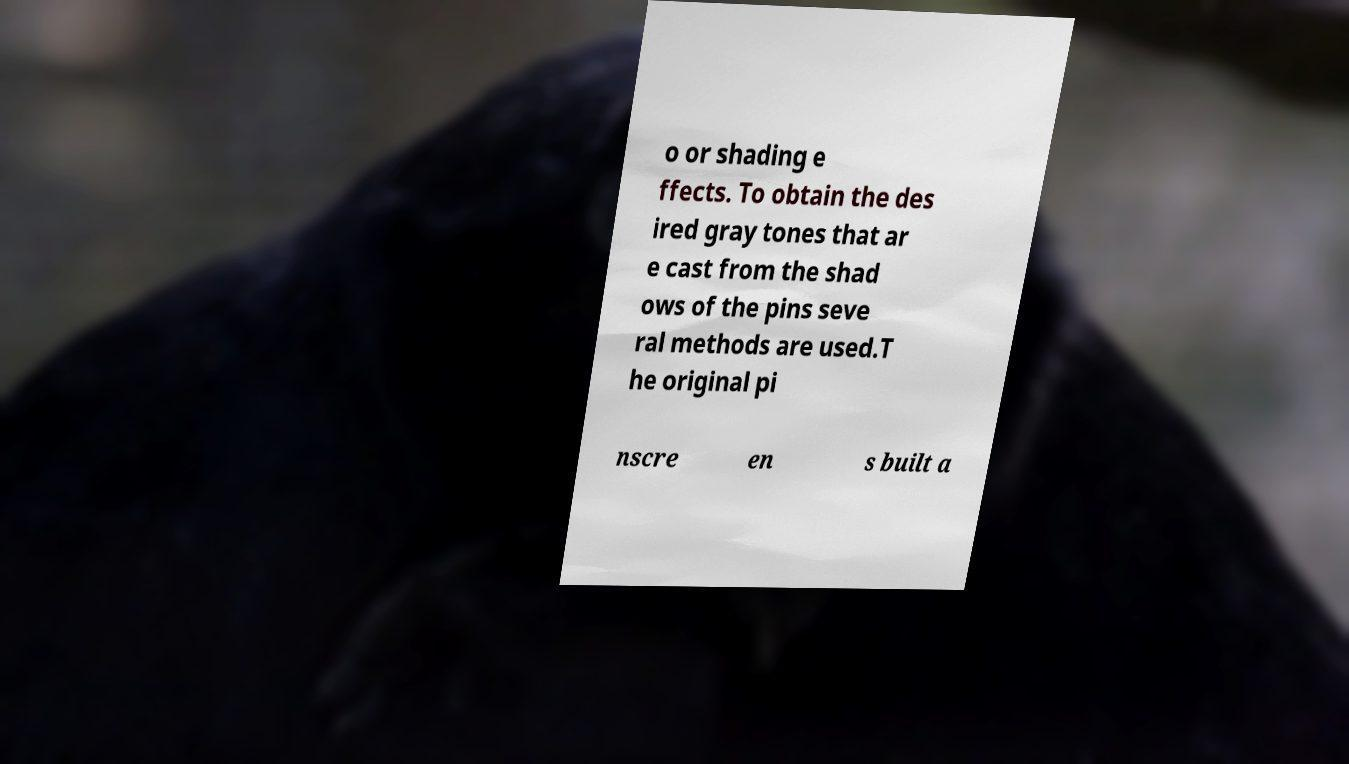I need the written content from this picture converted into text. Can you do that? o or shading e ffects. To obtain the des ired gray tones that ar e cast from the shad ows of the pins seve ral methods are used.T he original pi nscre en s built a 